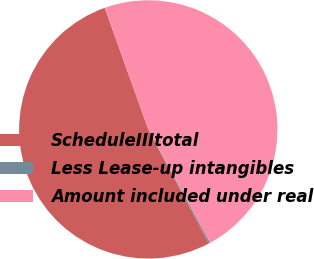Convert chart. <chart><loc_0><loc_0><loc_500><loc_500><pie_chart><fcel>ScheduleIIItotal<fcel>Less Lease-up intangibles<fcel>Amount included under real<nl><fcel>52.27%<fcel>0.2%<fcel>47.52%<nl></chart> 